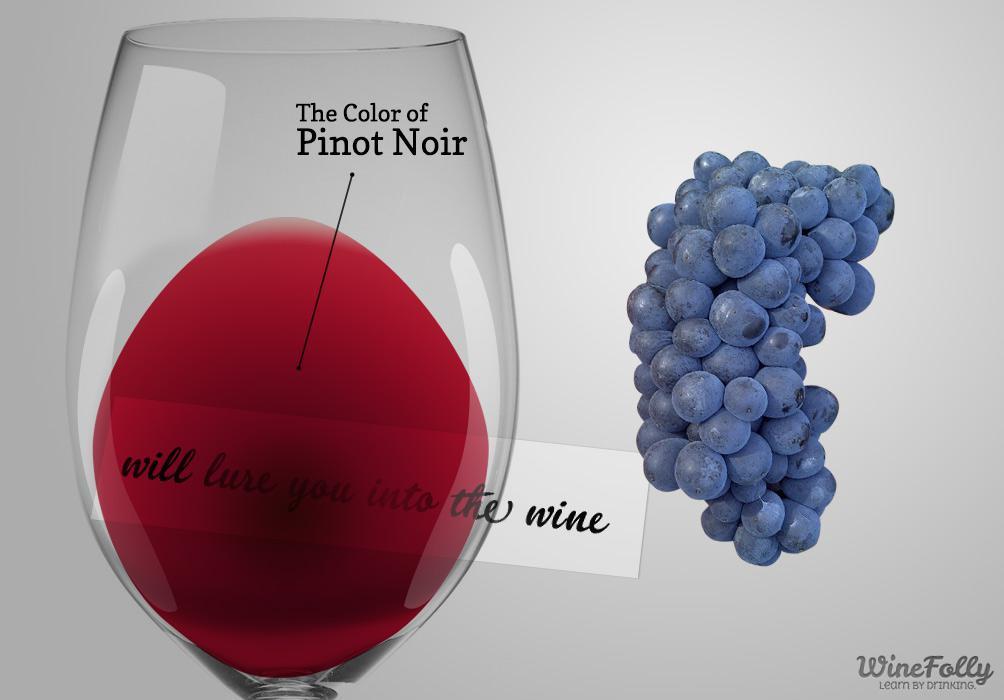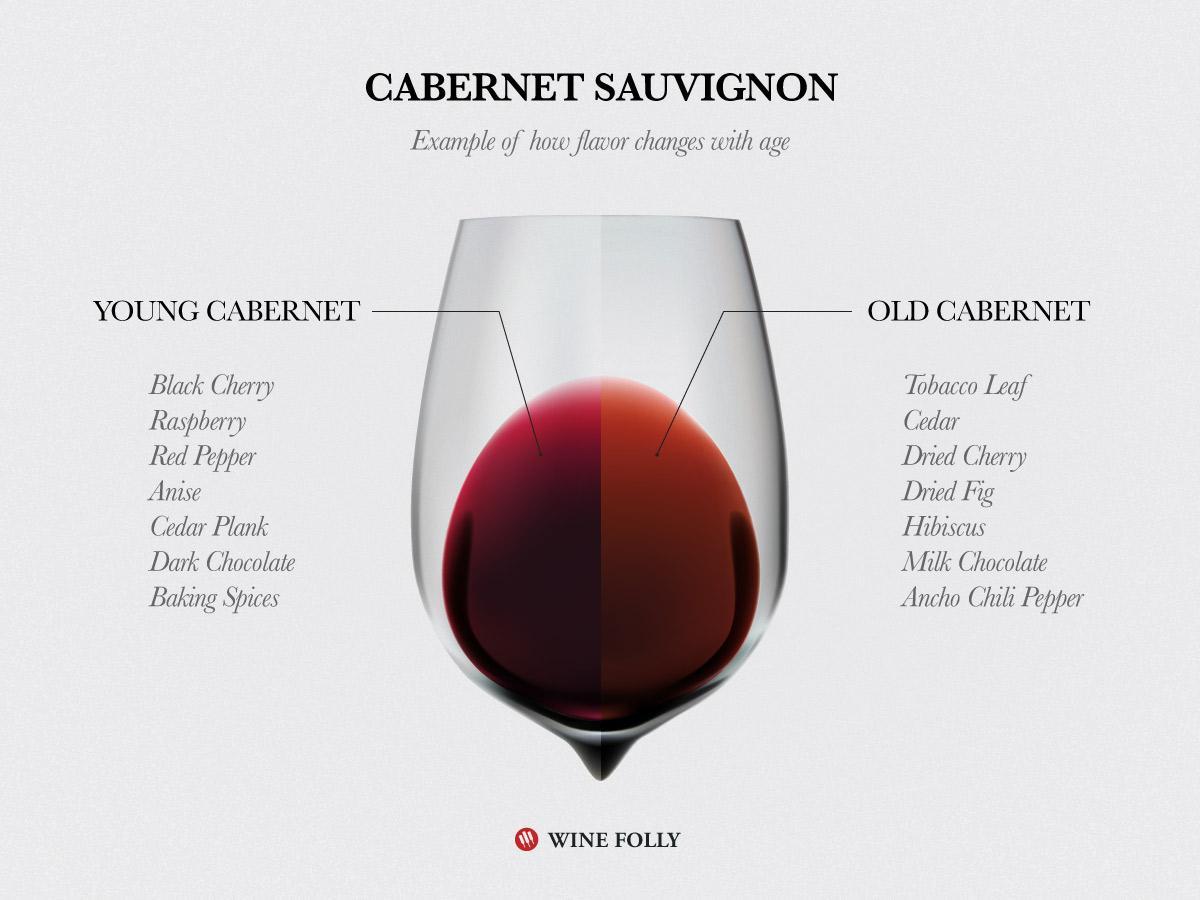The first image is the image on the left, the second image is the image on the right. Evaluate the accuracy of this statement regarding the images: "The wineglass in the image on the right appears to have a point at its base.". Is it true? Answer yes or no. Yes. 